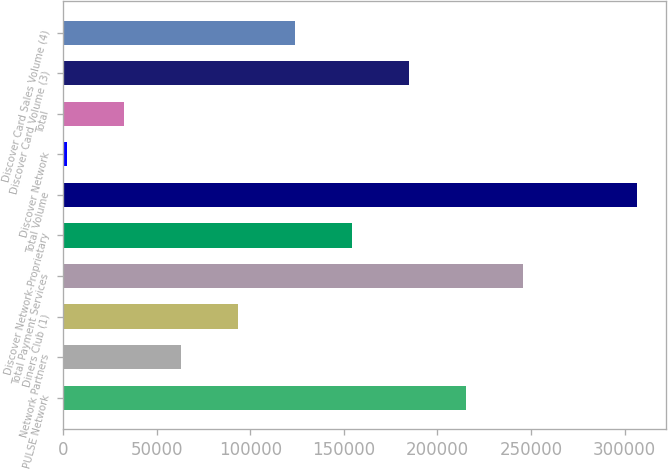Convert chart. <chart><loc_0><loc_0><loc_500><loc_500><bar_chart><fcel>PULSE Network<fcel>Network Partners<fcel>Diners Club (1)<fcel>Total Payment Services<fcel>Discover Network-Proprietary<fcel>Total Volume<fcel>Discover Network<fcel>Total<fcel>Discover Card Volume (3)<fcel>Discover Card Sales Volume (4)<nl><fcel>215244<fcel>63016.2<fcel>93461.8<fcel>245690<fcel>154353<fcel>306581<fcel>2125<fcel>32570.6<fcel>184799<fcel>123907<nl></chart> 